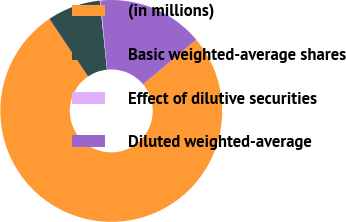Convert chart to OTSL. <chart><loc_0><loc_0><loc_500><loc_500><pie_chart><fcel>(in millions)<fcel>Basic weighted-average shares<fcel>Effect of dilutive securities<fcel>Diluted weighted-average<nl><fcel>76.7%<fcel>7.77%<fcel>0.11%<fcel>15.43%<nl></chart> 